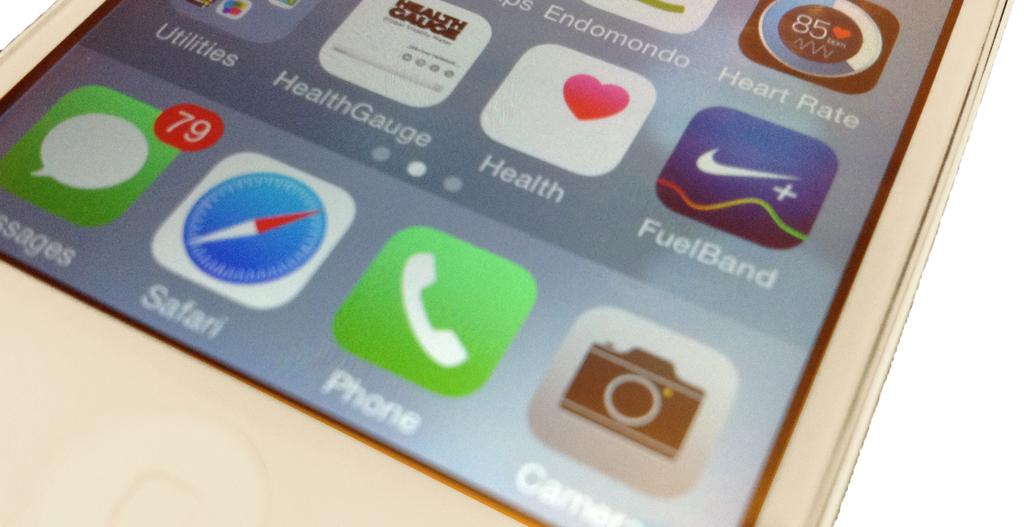<image>
Write a terse but informative summary of the picture. An iphone with 79 messages and FuelBand, Health, and Heart Rate apps showing 